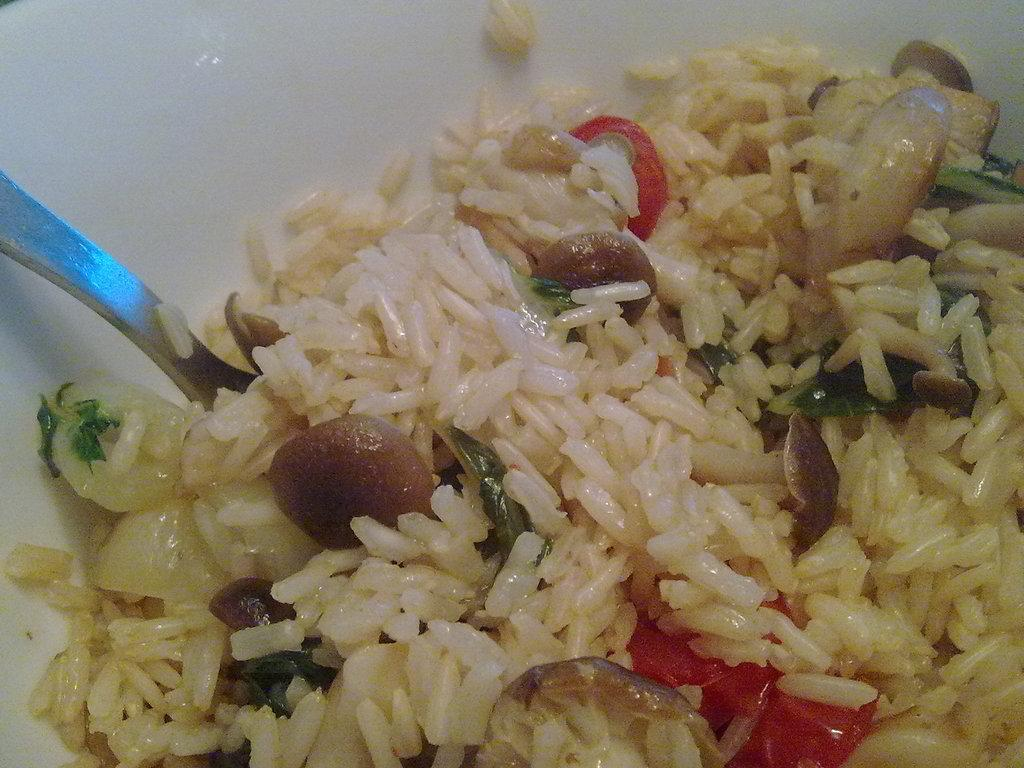What is present on the plate in the image? The plate contains food. What utensil is present with the food on the plate? There is a spoon in the plate. What is the tendency of the rain in the image? There is no rain present in the image. What type of basket is visible in the image? There is no basket present in the image. 